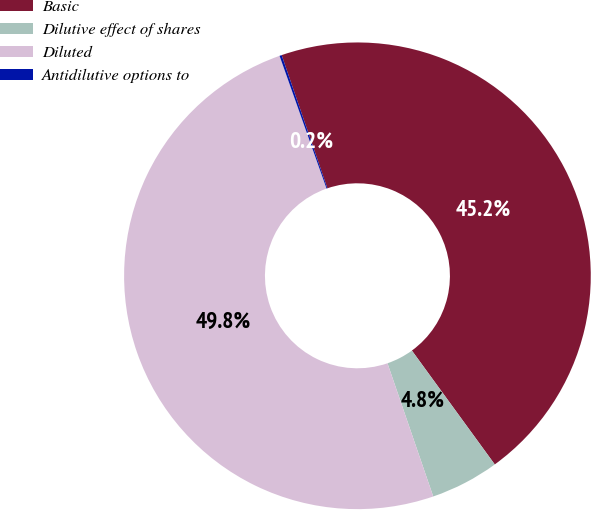Convert chart. <chart><loc_0><loc_0><loc_500><loc_500><pie_chart><fcel>Basic<fcel>Dilutive effect of shares<fcel>Diluted<fcel>Antidilutive options to<nl><fcel>45.25%<fcel>4.75%<fcel>49.85%<fcel>0.15%<nl></chart> 